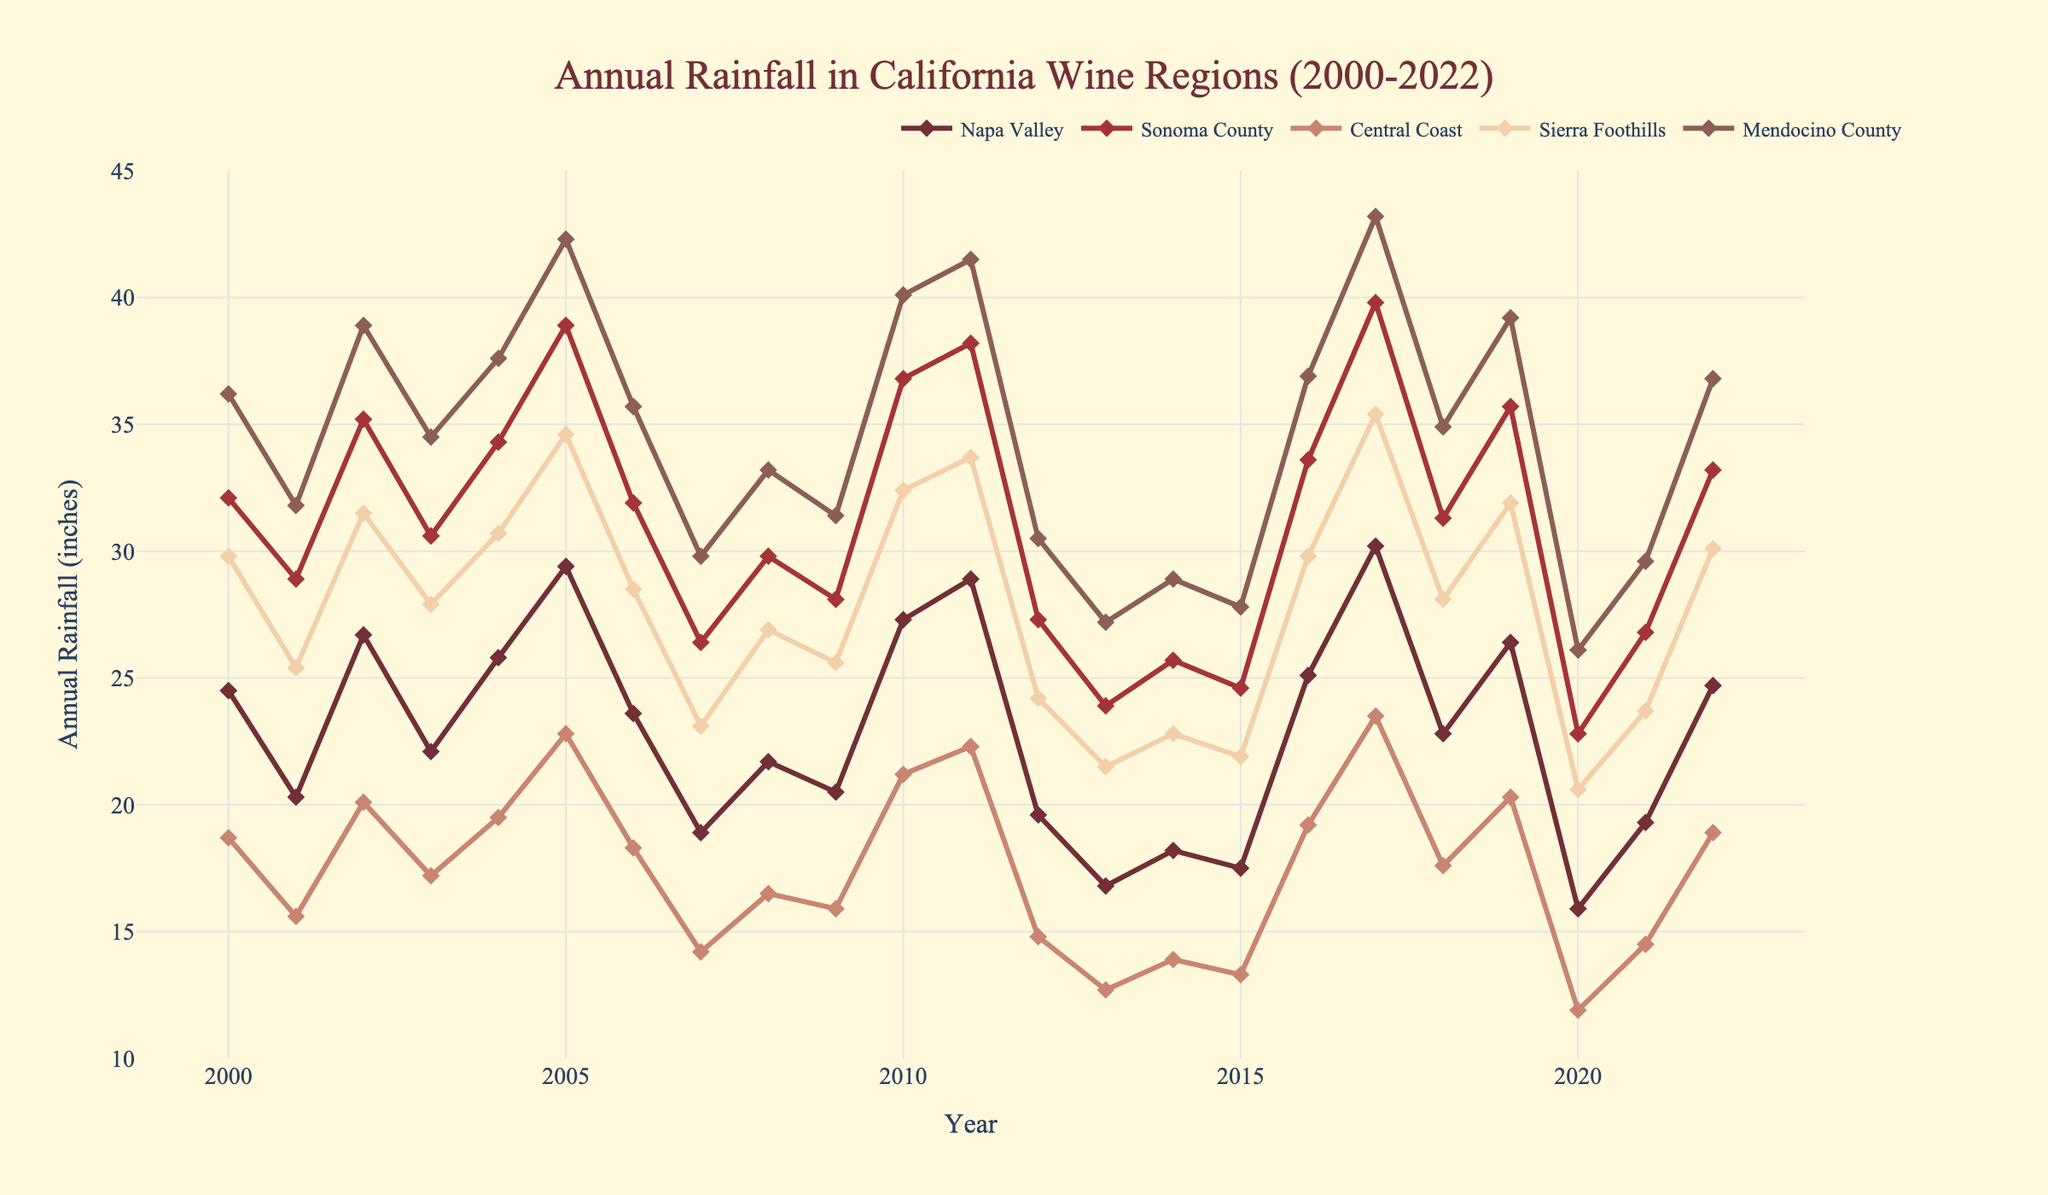What was the annual rainfall in Napa Valley in 2017? Look at the point corresponding to the year 2017 on the line for Napa Valley.
Answer: 30.2 inches Which wine region had the highest rainfall in 2005, and what was it? Identify the highest point among all regions for the year 2005 and check the region.
Answer: Mendocino County, 42.3 inches Compare the rainfall in Sonoma County in 2013 and 2020. Which year had more rainfall and by how much? Find the values for Sonoma County in 2013 and 2020 and subtract to find the difference.
Answer: 2013 had 1.1 inches more (23.9 - 22.8 = 1.1) What was the average annual rainfall in the Central Coast from 2010 to 2015? Add the annual rainfall values for the Central Coast from 2010 to 2015 and then divide by 6.
Answer: (21.2 + 22.3 + 14.8 + 12.7 + 13.9 + 13.3) / 6 = 16.37 inches In which year did the Sierra Foothills experience the lowest annual rainfall and what was the value? Look for the minimum point on the line for Sierra Foothills and check the corresponding year.
Answer: 2020, 20.6 inches How did the annual rainfall trend in Mendocino County between 2017 and 2020 compare to that in Central Coast? Trace the lines for both regions from 2017 to 2020 and observe the trends.
Answer: Both regions show a decreasing trend Calculate the difference in annual rainfall between Napa Valley and Sonoma County in 2003. Subtract the rainfall value of Napa Valley from that of Sonoma County for 2003.
Answer: 30.6 - 22.1 = 8.5 inches Which region experienced the most consistent rainfall pattern between 2000 and 2022, based on visual inspection? Observe the lines for all regions and identify the one with the least fluctuation.
Answer: Central Coast What was the percentage increase in annual rainfall for Napa Valley from 2016 to 2017? Calculate the percentage increase using the formula [(30.2 - 25.1)/25.1] * 100.
Answer: 20.3% When did Sonoma County experience rainfall of approximately 26.4 inches? Locate the point on the Sonoma County line closest to 26.4 inches and note the year.
Answer: 2007 